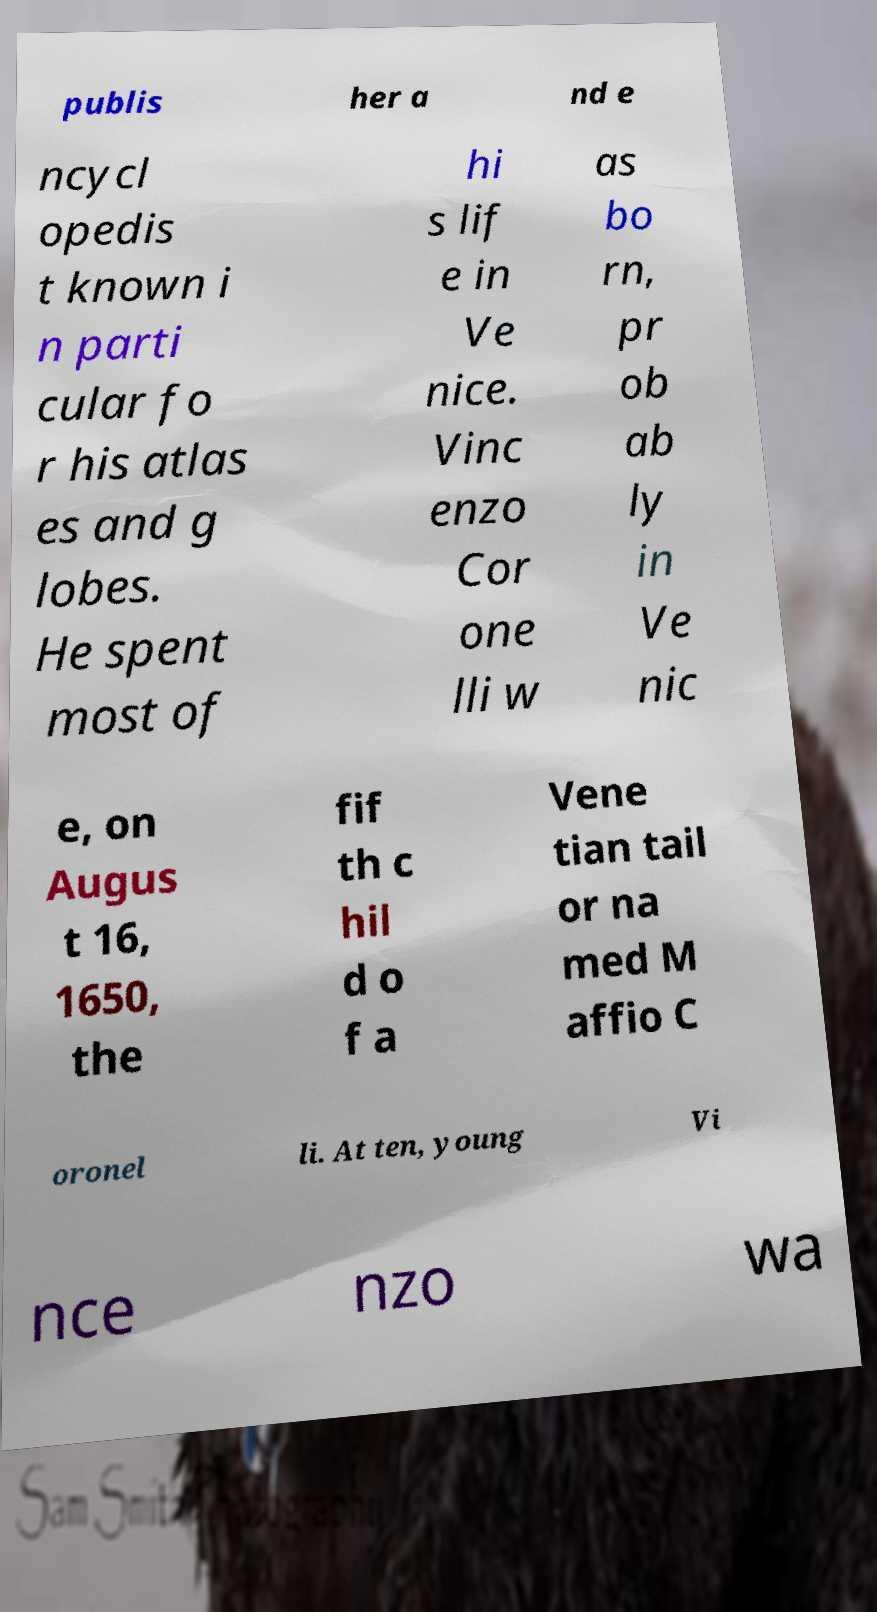Please read and relay the text visible in this image. What does it say? publis her a nd e ncycl opedis t known i n parti cular fo r his atlas es and g lobes. He spent most of hi s lif e in Ve nice. Vinc enzo Cor one lli w as bo rn, pr ob ab ly in Ve nic e, on Augus t 16, 1650, the fif th c hil d o f a Vene tian tail or na med M affio C oronel li. At ten, young Vi nce nzo wa 